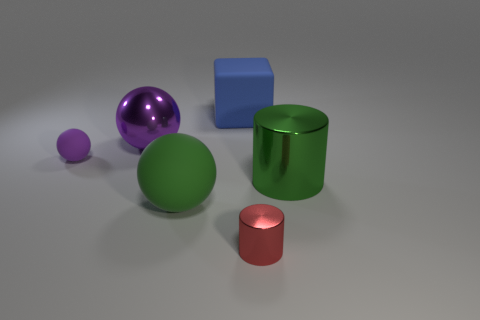How many objects are behind the red thing and in front of the big green metal thing?
Keep it short and to the point. 1. What material is the green cylinder on the right side of the blue rubber block on the right side of the purple metallic thing?
Make the answer very short. Metal. What is the material of the big thing that is the same shape as the tiny red thing?
Offer a very short reply. Metal. Is there a metal cylinder?
Ensure brevity in your answer.  Yes. The large green thing that is the same material as the red cylinder is what shape?
Provide a short and direct response. Cylinder. What is the object to the right of the tiny cylinder made of?
Make the answer very short. Metal. There is a rubber sphere in front of the purple rubber sphere; is its color the same as the small metal cylinder?
Provide a short and direct response. No. How big is the green thing on the left side of the large rubber object that is behind the large metal sphere?
Your answer should be very brief. Large. Is the number of big green cylinders in front of the large rubber ball greater than the number of tiny purple matte balls?
Ensure brevity in your answer.  No. There is a green thing to the right of the blue matte block; does it have the same size as the tiny red metallic object?
Offer a very short reply. No. 